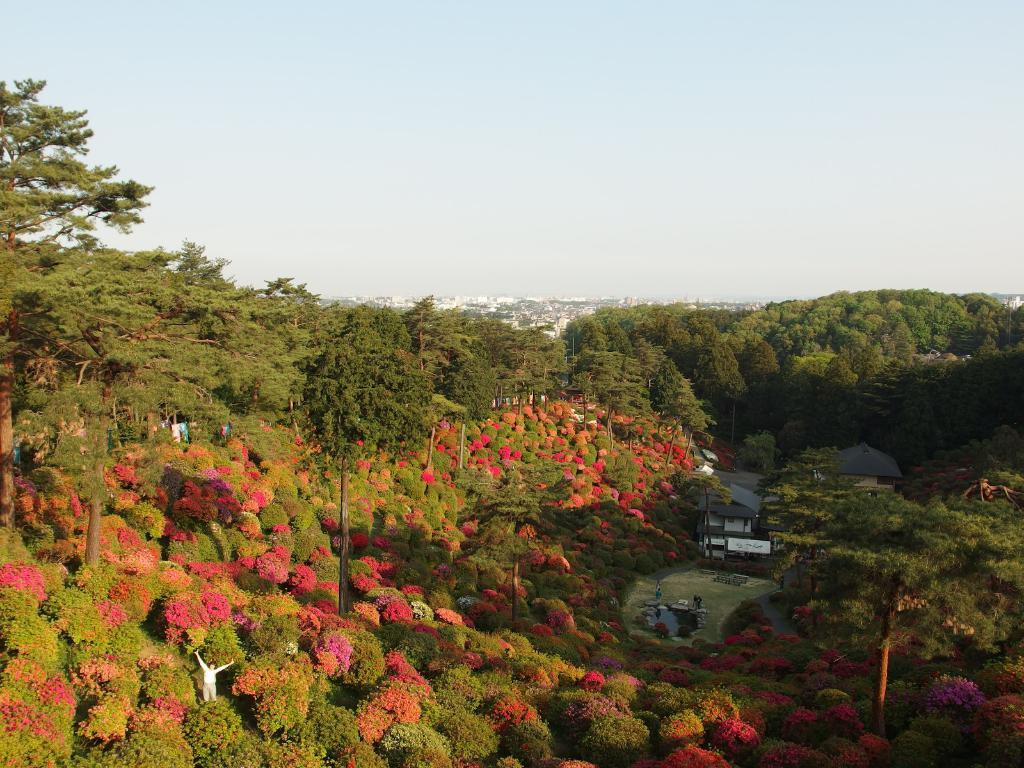What type of vegetation can be seen in the image? There are trees in the image. What structures are present in the image? There are poles and houses in the image. What type of ground surface is visible in the image? There is grass in the image. What is the person in the image doing? There is a person standing at the bottom of the image. What is visible at the top of the image? The sky is visible at the top of the image. What type of ink is being used by the person in the image? There is no ink present in the image, as it features a person standing in a grassy area with trees, poles, and houses. What behavior is the person exhibiting in the image? The provided facts do not mention any specific behavior of the person in the image, so it cannot be determined from the image alone. 